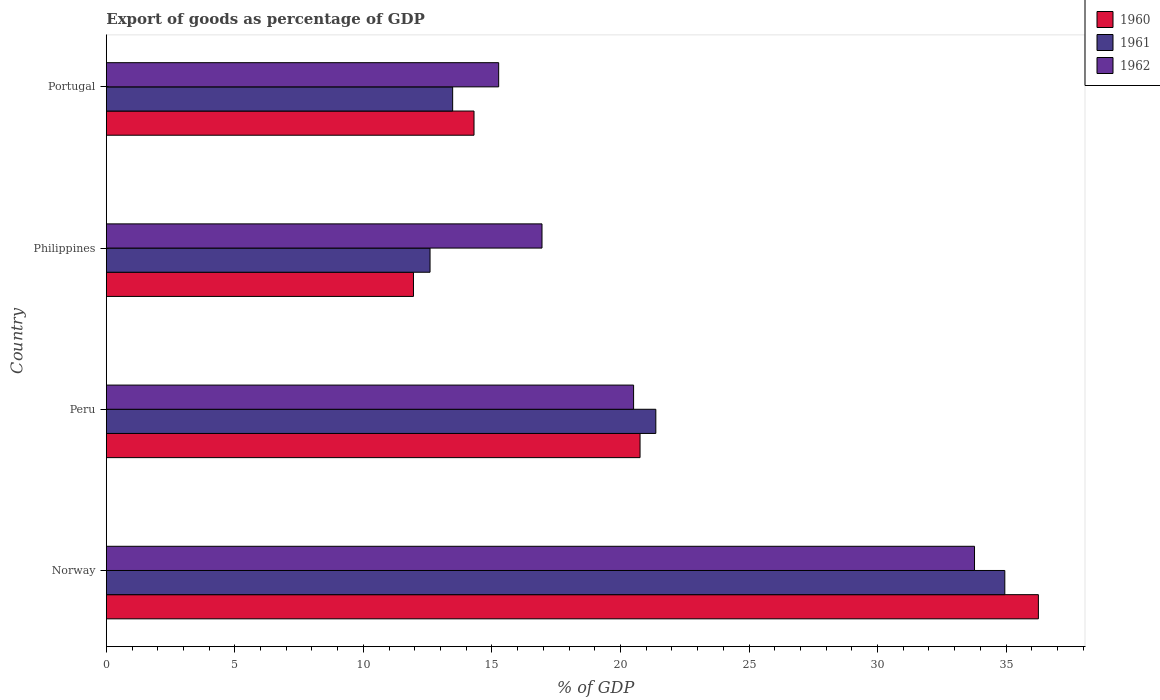How many different coloured bars are there?
Provide a short and direct response. 3. Are the number of bars on each tick of the Y-axis equal?
Give a very brief answer. Yes. How many bars are there on the 4th tick from the top?
Provide a short and direct response. 3. How many bars are there on the 1st tick from the bottom?
Provide a short and direct response. 3. What is the export of goods as percentage of GDP in 1961 in Portugal?
Offer a terse response. 13.47. Across all countries, what is the maximum export of goods as percentage of GDP in 1960?
Provide a succinct answer. 36.26. Across all countries, what is the minimum export of goods as percentage of GDP in 1961?
Your response must be concise. 12.59. In which country was the export of goods as percentage of GDP in 1962 maximum?
Ensure brevity in your answer.  Norway. What is the total export of goods as percentage of GDP in 1960 in the graph?
Provide a short and direct response. 83.27. What is the difference between the export of goods as percentage of GDP in 1960 in Norway and that in Peru?
Your response must be concise. 15.5. What is the difference between the export of goods as percentage of GDP in 1961 in Peru and the export of goods as percentage of GDP in 1962 in Portugal?
Your answer should be compact. 6.11. What is the average export of goods as percentage of GDP in 1960 per country?
Give a very brief answer. 20.82. What is the difference between the export of goods as percentage of GDP in 1961 and export of goods as percentage of GDP in 1960 in Philippines?
Ensure brevity in your answer.  0.65. In how many countries, is the export of goods as percentage of GDP in 1961 greater than 29 %?
Your answer should be very brief. 1. What is the ratio of the export of goods as percentage of GDP in 1961 in Peru to that in Philippines?
Your response must be concise. 1.7. Is the export of goods as percentage of GDP in 1962 in Philippines less than that in Portugal?
Your answer should be compact. No. Is the difference between the export of goods as percentage of GDP in 1961 in Norway and Portugal greater than the difference between the export of goods as percentage of GDP in 1960 in Norway and Portugal?
Keep it short and to the point. No. What is the difference between the highest and the second highest export of goods as percentage of GDP in 1961?
Make the answer very short. 13.58. What is the difference between the highest and the lowest export of goods as percentage of GDP in 1962?
Your answer should be very brief. 18.51. In how many countries, is the export of goods as percentage of GDP in 1962 greater than the average export of goods as percentage of GDP in 1962 taken over all countries?
Offer a very short reply. 1. Is the sum of the export of goods as percentage of GDP in 1961 in Peru and Portugal greater than the maximum export of goods as percentage of GDP in 1962 across all countries?
Make the answer very short. Yes. Is it the case that in every country, the sum of the export of goods as percentage of GDP in 1961 and export of goods as percentage of GDP in 1960 is greater than the export of goods as percentage of GDP in 1962?
Your response must be concise. Yes. How many bars are there?
Provide a short and direct response. 12. Are all the bars in the graph horizontal?
Provide a succinct answer. Yes. How many countries are there in the graph?
Offer a very short reply. 4. What is the difference between two consecutive major ticks on the X-axis?
Offer a very short reply. 5. Does the graph contain any zero values?
Give a very brief answer. No. Does the graph contain grids?
Offer a very short reply. No. Where does the legend appear in the graph?
Offer a terse response. Top right. How are the legend labels stacked?
Provide a short and direct response. Vertical. What is the title of the graph?
Give a very brief answer. Export of goods as percentage of GDP. Does "1977" appear as one of the legend labels in the graph?
Your answer should be very brief. No. What is the label or title of the X-axis?
Provide a succinct answer. % of GDP. What is the % of GDP in 1960 in Norway?
Give a very brief answer. 36.26. What is the % of GDP of 1961 in Norway?
Ensure brevity in your answer.  34.95. What is the % of GDP in 1962 in Norway?
Offer a very short reply. 33.77. What is the % of GDP of 1960 in Peru?
Your response must be concise. 20.76. What is the % of GDP of 1961 in Peru?
Ensure brevity in your answer.  21.38. What is the % of GDP of 1962 in Peru?
Make the answer very short. 20.51. What is the % of GDP of 1960 in Philippines?
Your response must be concise. 11.95. What is the % of GDP of 1961 in Philippines?
Provide a short and direct response. 12.59. What is the % of GDP of 1962 in Philippines?
Offer a terse response. 16.95. What is the % of GDP of 1960 in Portugal?
Make the answer very short. 14.3. What is the % of GDP of 1961 in Portugal?
Ensure brevity in your answer.  13.47. What is the % of GDP in 1962 in Portugal?
Provide a short and direct response. 15.26. Across all countries, what is the maximum % of GDP in 1960?
Your answer should be very brief. 36.26. Across all countries, what is the maximum % of GDP of 1961?
Your response must be concise. 34.95. Across all countries, what is the maximum % of GDP in 1962?
Your response must be concise. 33.77. Across all countries, what is the minimum % of GDP in 1960?
Keep it short and to the point. 11.95. Across all countries, what is the minimum % of GDP of 1961?
Your answer should be compact. 12.59. Across all countries, what is the minimum % of GDP in 1962?
Your answer should be compact. 15.26. What is the total % of GDP in 1960 in the graph?
Make the answer very short. 83.27. What is the total % of GDP of 1961 in the graph?
Ensure brevity in your answer.  82.39. What is the total % of GDP in 1962 in the graph?
Offer a terse response. 86.49. What is the difference between the % of GDP in 1960 in Norway and that in Peru?
Provide a succinct answer. 15.5. What is the difference between the % of GDP in 1961 in Norway and that in Peru?
Your response must be concise. 13.58. What is the difference between the % of GDP in 1962 in Norway and that in Peru?
Provide a short and direct response. 13.26. What is the difference between the % of GDP of 1960 in Norway and that in Philippines?
Your answer should be compact. 24.31. What is the difference between the % of GDP of 1961 in Norway and that in Philippines?
Your answer should be very brief. 22.36. What is the difference between the % of GDP in 1962 in Norway and that in Philippines?
Your answer should be very brief. 16.82. What is the difference between the % of GDP of 1960 in Norway and that in Portugal?
Your response must be concise. 21.95. What is the difference between the % of GDP of 1961 in Norway and that in Portugal?
Offer a terse response. 21.48. What is the difference between the % of GDP of 1962 in Norway and that in Portugal?
Ensure brevity in your answer.  18.51. What is the difference between the % of GDP in 1960 in Peru and that in Philippines?
Ensure brevity in your answer.  8.81. What is the difference between the % of GDP of 1961 in Peru and that in Philippines?
Make the answer very short. 8.78. What is the difference between the % of GDP of 1962 in Peru and that in Philippines?
Make the answer very short. 3.56. What is the difference between the % of GDP in 1960 in Peru and that in Portugal?
Provide a succinct answer. 6.46. What is the difference between the % of GDP of 1961 in Peru and that in Portugal?
Offer a very short reply. 7.9. What is the difference between the % of GDP in 1962 in Peru and that in Portugal?
Keep it short and to the point. 5.25. What is the difference between the % of GDP in 1960 in Philippines and that in Portugal?
Make the answer very short. -2.36. What is the difference between the % of GDP in 1961 in Philippines and that in Portugal?
Offer a terse response. -0.88. What is the difference between the % of GDP of 1962 in Philippines and that in Portugal?
Ensure brevity in your answer.  1.69. What is the difference between the % of GDP of 1960 in Norway and the % of GDP of 1961 in Peru?
Make the answer very short. 14.88. What is the difference between the % of GDP of 1960 in Norway and the % of GDP of 1962 in Peru?
Your answer should be compact. 15.75. What is the difference between the % of GDP of 1961 in Norway and the % of GDP of 1962 in Peru?
Your answer should be compact. 14.44. What is the difference between the % of GDP of 1960 in Norway and the % of GDP of 1961 in Philippines?
Ensure brevity in your answer.  23.66. What is the difference between the % of GDP of 1960 in Norway and the % of GDP of 1962 in Philippines?
Ensure brevity in your answer.  19.31. What is the difference between the % of GDP in 1961 in Norway and the % of GDP in 1962 in Philippines?
Keep it short and to the point. 18. What is the difference between the % of GDP in 1960 in Norway and the % of GDP in 1961 in Portugal?
Offer a terse response. 22.79. What is the difference between the % of GDP in 1960 in Norway and the % of GDP in 1962 in Portugal?
Your response must be concise. 21. What is the difference between the % of GDP in 1961 in Norway and the % of GDP in 1962 in Portugal?
Provide a succinct answer. 19.69. What is the difference between the % of GDP of 1960 in Peru and the % of GDP of 1961 in Philippines?
Ensure brevity in your answer.  8.17. What is the difference between the % of GDP of 1960 in Peru and the % of GDP of 1962 in Philippines?
Your response must be concise. 3.81. What is the difference between the % of GDP in 1961 in Peru and the % of GDP in 1962 in Philippines?
Offer a very short reply. 4.43. What is the difference between the % of GDP of 1960 in Peru and the % of GDP of 1961 in Portugal?
Your response must be concise. 7.29. What is the difference between the % of GDP in 1960 in Peru and the % of GDP in 1962 in Portugal?
Provide a succinct answer. 5.5. What is the difference between the % of GDP in 1961 in Peru and the % of GDP in 1962 in Portugal?
Your answer should be compact. 6.11. What is the difference between the % of GDP of 1960 in Philippines and the % of GDP of 1961 in Portugal?
Your answer should be compact. -1.52. What is the difference between the % of GDP of 1960 in Philippines and the % of GDP of 1962 in Portugal?
Your response must be concise. -3.31. What is the difference between the % of GDP of 1961 in Philippines and the % of GDP of 1962 in Portugal?
Keep it short and to the point. -2.67. What is the average % of GDP of 1960 per country?
Keep it short and to the point. 20.82. What is the average % of GDP of 1961 per country?
Give a very brief answer. 20.6. What is the average % of GDP of 1962 per country?
Your response must be concise. 21.62. What is the difference between the % of GDP of 1960 and % of GDP of 1961 in Norway?
Ensure brevity in your answer.  1.31. What is the difference between the % of GDP of 1960 and % of GDP of 1962 in Norway?
Provide a succinct answer. 2.48. What is the difference between the % of GDP in 1961 and % of GDP in 1962 in Norway?
Provide a short and direct response. 1.18. What is the difference between the % of GDP in 1960 and % of GDP in 1961 in Peru?
Your answer should be compact. -0.61. What is the difference between the % of GDP of 1960 and % of GDP of 1962 in Peru?
Provide a succinct answer. 0.25. What is the difference between the % of GDP of 1961 and % of GDP of 1962 in Peru?
Keep it short and to the point. 0.86. What is the difference between the % of GDP in 1960 and % of GDP in 1961 in Philippines?
Your answer should be very brief. -0.65. What is the difference between the % of GDP in 1960 and % of GDP in 1962 in Philippines?
Your answer should be very brief. -5. What is the difference between the % of GDP of 1961 and % of GDP of 1962 in Philippines?
Provide a succinct answer. -4.36. What is the difference between the % of GDP in 1960 and % of GDP in 1961 in Portugal?
Your answer should be compact. 0.83. What is the difference between the % of GDP of 1960 and % of GDP of 1962 in Portugal?
Give a very brief answer. -0.96. What is the difference between the % of GDP in 1961 and % of GDP in 1962 in Portugal?
Provide a succinct answer. -1.79. What is the ratio of the % of GDP in 1960 in Norway to that in Peru?
Your answer should be compact. 1.75. What is the ratio of the % of GDP of 1961 in Norway to that in Peru?
Your response must be concise. 1.64. What is the ratio of the % of GDP in 1962 in Norway to that in Peru?
Make the answer very short. 1.65. What is the ratio of the % of GDP in 1960 in Norway to that in Philippines?
Make the answer very short. 3.03. What is the ratio of the % of GDP of 1961 in Norway to that in Philippines?
Make the answer very short. 2.78. What is the ratio of the % of GDP in 1962 in Norway to that in Philippines?
Your answer should be compact. 1.99. What is the ratio of the % of GDP in 1960 in Norway to that in Portugal?
Your answer should be compact. 2.54. What is the ratio of the % of GDP of 1961 in Norway to that in Portugal?
Offer a very short reply. 2.59. What is the ratio of the % of GDP in 1962 in Norway to that in Portugal?
Offer a very short reply. 2.21. What is the ratio of the % of GDP in 1960 in Peru to that in Philippines?
Give a very brief answer. 1.74. What is the ratio of the % of GDP of 1961 in Peru to that in Philippines?
Your answer should be very brief. 1.7. What is the ratio of the % of GDP of 1962 in Peru to that in Philippines?
Your response must be concise. 1.21. What is the ratio of the % of GDP in 1960 in Peru to that in Portugal?
Keep it short and to the point. 1.45. What is the ratio of the % of GDP of 1961 in Peru to that in Portugal?
Keep it short and to the point. 1.59. What is the ratio of the % of GDP of 1962 in Peru to that in Portugal?
Your response must be concise. 1.34. What is the ratio of the % of GDP in 1960 in Philippines to that in Portugal?
Your answer should be compact. 0.84. What is the ratio of the % of GDP of 1961 in Philippines to that in Portugal?
Your answer should be compact. 0.93. What is the ratio of the % of GDP of 1962 in Philippines to that in Portugal?
Your answer should be compact. 1.11. What is the difference between the highest and the second highest % of GDP in 1960?
Offer a terse response. 15.5. What is the difference between the highest and the second highest % of GDP of 1961?
Your response must be concise. 13.58. What is the difference between the highest and the second highest % of GDP in 1962?
Ensure brevity in your answer.  13.26. What is the difference between the highest and the lowest % of GDP of 1960?
Your answer should be compact. 24.31. What is the difference between the highest and the lowest % of GDP of 1961?
Keep it short and to the point. 22.36. What is the difference between the highest and the lowest % of GDP of 1962?
Your response must be concise. 18.51. 